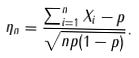Convert formula to latex. <formula><loc_0><loc_0><loc_500><loc_500>\eta _ { n } = \frac { \sum _ { i = 1 } ^ { n } X _ { i } - p } { \sqrt { n p ( 1 - p ) } } .</formula> 